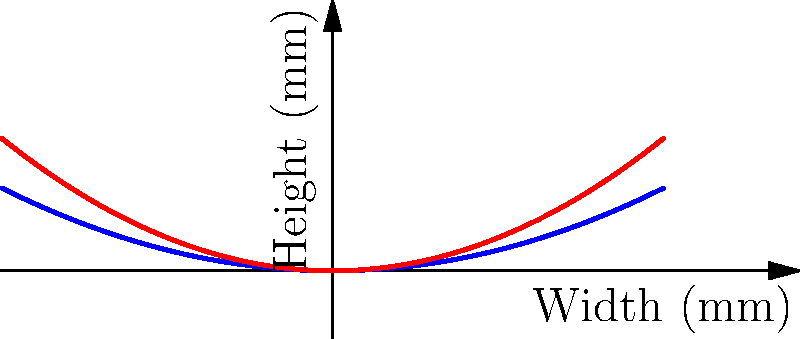A violinist is experimenting with different bridge curvatures to optimize sound projection. The standard bridge has a curvature described by the function $h(x) = 0.05x^2$, where $x$ is the distance from the center in millimeters and $h(x)$ is the height. If the violinist tries a flatter bridge with a curvature of $h(x) = 0.08x^2$, how much higher (in mm) will the E string be compared to the standard bridge, assuming the E string is positioned 16 mm from the center of the bridge? Let's approach this step-by-step:

1) For the standard bridge, the height at the E string position is given by:
   $h_1(x) = 0.05x^2$
   $h_1(16) = 0.05 \cdot 16^2 = 0.05 \cdot 256 = 12.8$ mm

2) For the flatter bridge, the height at the E string position is given by:
   $h_2(x) = 0.08x^2$
   $h_2(16) = 0.08 \cdot 16^2 = 0.08 \cdot 256 = 20.48$ mm

3) The difference in height is:
   $\Delta h = h_2(16) - h_1(16) = 20.48 - 12.8 = 7.68$ mm

Therefore, the E string will be 7.68 mm higher on the flatter bridge compared to the standard bridge.
Answer: 7.68 mm 